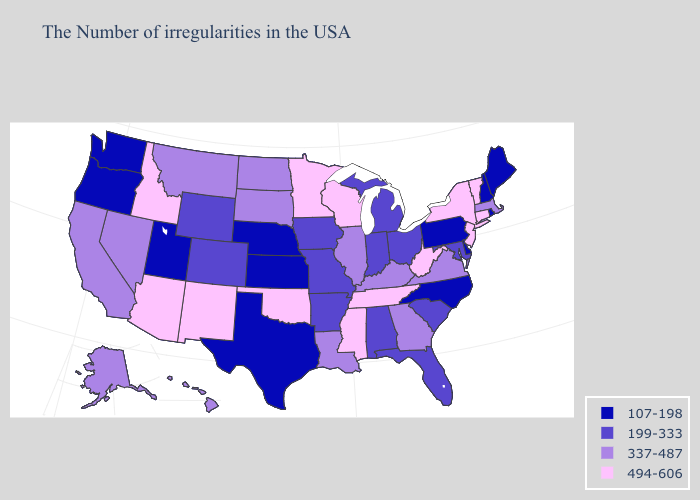Name the states that have a value in the range 199-333?
Give a very brief answer. Maryland, South Carolina, Ohio, Florida, Michigan, Indiana, Alabama, Missouri, Arkansas, Iowa, Wyoming, Colorado. Name the states that have a value in the range 337-487?
Short answer required. Massachusetts, Virginia, Georgia, Kentucky, Illinois, Louisiana, South Dakota, North Dakota, Montana, Nevada, California, Alaska, Hawaii. What is the highest value in the South ?
Give a very brief answer. 494-606. What is the value of Oklahoma?
Short answer required. 494-606. Name the states that have a value in the range 199-333?
Give a very brief answer. Maryland, South Carolina, Ohio, Florida, Michigan, Indiana, Alabama, Missouri, Arkansas, Iowa, Wyoming, Colorado. Does Texas have the same value as Nebraska?
Short answer required. Yes. Name the states that have a value in the range 337-487?
Give a very brief answer. Massachusetts, Virginia, Georgia, Kentucky, Illinois, Louisiana, South Dakota, North Dakota, Montana, Nevada, California, Alaska, Hawaii. Name the states that have a value in the range 337-487?
Short answer required. Massachusetts, Virginia, Georgia, Kentucky, Illinois, Louisiana, South Dakota, North Dakota, Montana, Nevada, California, Alaska, Hawaii. What is the value of Michigan?
Short answer required. 199-333. Name the states that have a value in the range 107-198?
Answer briefly. Maine, Rhode Island, New Hampshire, Delaware, Pennsylvania, North Carolina, Kansas, Nebraska, Texas, Utah, Washington, Oregon. What is the highest value in states that border Arizona?
Concise answer only. 494-606. Does Nebraska have the lowest value in the MidWest?
Keep it brief. Yes. Among the states that border Massachusetts , which have the lowest value?
Short answer required. Rhode Island, New Hampshire. Does Wisconsin have the highest value in the USA?
Keep it brief. Yes. What is the highest value in states that border Oregon?
Quick response, please. 494-606. 